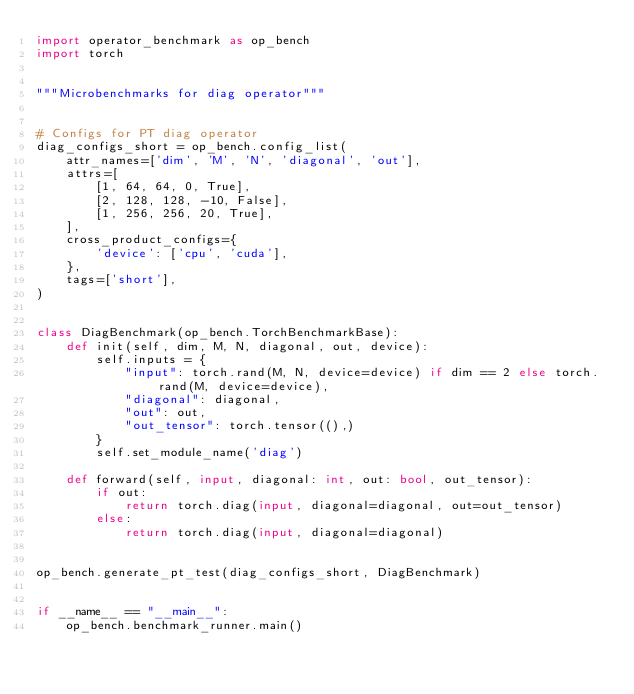<code> <loc_0><loc_0><loc_500><loc_500><_Python_>import operator_benchmark as op_bench
import torch


"""Microbenchmarks for diag operator"""


# Configs for PT diag operator
diag_configs_short = op_bench.config_list(
    attr_names=['dim', 'M', 'N', 'diagonal', 'out'],
    attrs=[
        [1, 64, 64, 0, True],
        [2, 128, 128, -10, False],
        [1, 256, 256, 20, True],
    ],
    cross_product_configs={
        'device': ['cpu', 'cuda'],
    },
    tags=['short'],
)


class DiagBenchmark(op_bench.TorchBenchmarkBase):
    def init(self, dim, M, N, diagonal, out, device):
        self.inputs = {
            "input": torch.rand(M, N, device=device) if dim == 2 else torch.rand(M, device=device),
            "diagonal": diagonal,
            "out": out,
            "out_tensor": torch.tensor((),)
        }
        self.set_module_name('diag')

    def forward(self, input, diagonal: int, out: bool, out_tensor):
        if out:
            return torch.diag(input, diagonal=diagonal, out=out_tensor)
        else:
            return torch.diag(input, diagonal=diagonal)


op_bench.generate_pt_test(diag_configs_short, DiagBenchmark)


if __name__ == "__main__":
    op_bench.benchmark_runner.main()
</code> 